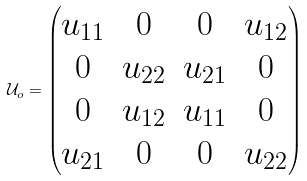Convert formula to latex. <formula><loc_0><loc_0><loc_500><loc_500>\mathcal { U } _ { o } = \begin{pmatrix} u _ { 1 1 } & 0 & 0 & u _ { 1 2 } \\ 0 & u _ { 2 2 } & u _ { 2 1 } & 0 \\ 0 & u _ { 1 2 } & u _ { 1 1 } & 0 \\ u _ { 2 1 } & 0 & 0 & u _ { 2 2 } \end{pmatrix}</formula> 